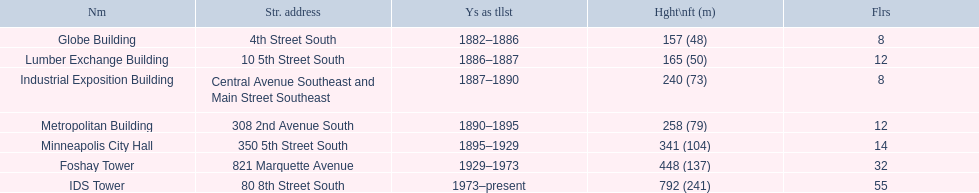How many floors does the lumber exchange building have? 12. What other building has 12 floors? Metropolitan Building. I'm looking to parse the entire table for insights. Could you assist me with that? {'header': ['Nm', 'Str. address', 'Ys as tllst', 'Hght\\nft (m)', 'Flrs'], 'rows': [['Globe Building', '4th Street South', '1882–1886', '157 (48)', '8'], ['Lumber Exchange Building', '10 5th Street South', '1886–1887', '165 (50)', '12'], ['Industrial Exposition Building', 'Central Avenue Southeast and Main Street Southeast', '1887–1890', '240 (73)', '8'], ['Metropolitan Building', '308 2nd Avenue South', '1890–1895', '258 (79)', '12'], ['Minneapolis City Hall', '350 5th Street South', '1895–1929', '341 (104)', '14'], ['Foshay Tower', '821 Marquette Avenue', '1929–1973', '448 (137)', '32'], ['IDS Tower', '80 8th Street South', '1973–present', '792 (241)', '55']]} 